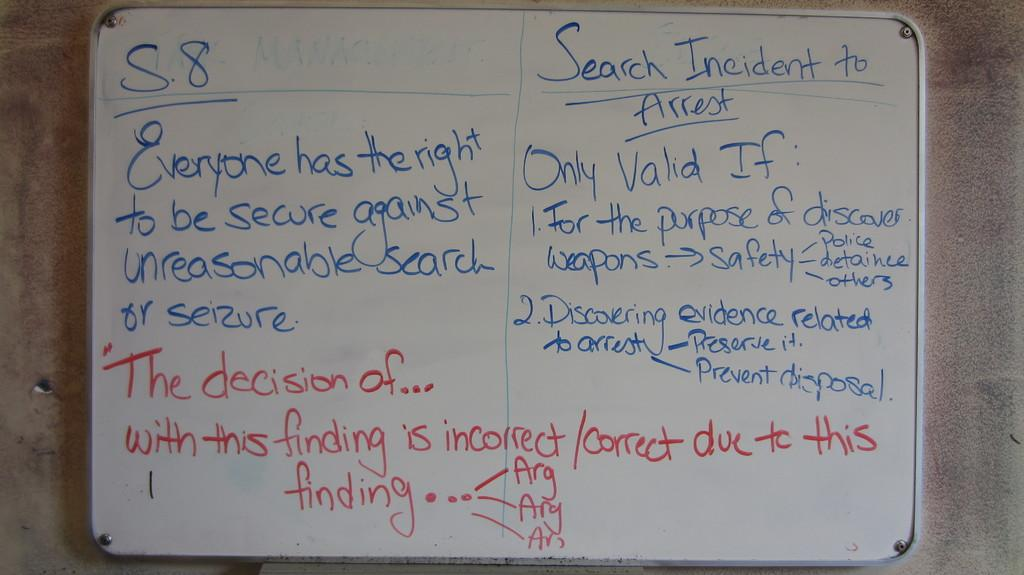<image>
Summarize the visual content of the image. A Board showing everyone's rights against search and seizure and when it is valid. 